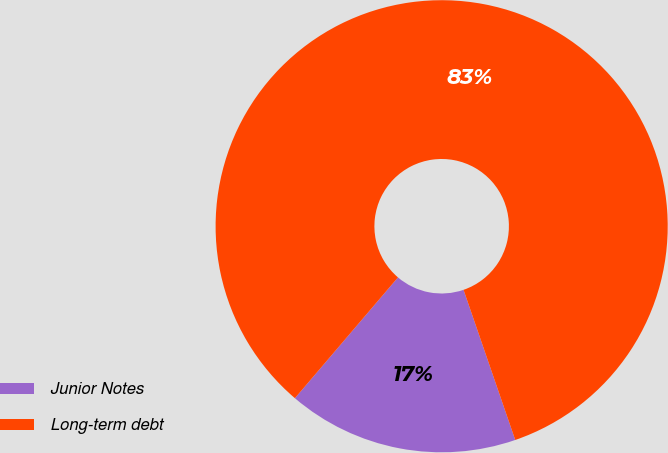Convert chart to OTSL. <chart><loc_0><loc_0><loc_500><loc_500><pie_chart><fcel>Junior Notes<fcel>Long-term debt<nl><fcel>16.52%<fcel>83.48%<nl></chart> 